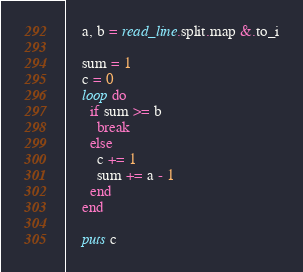<code> <loc_0><loc_0><loc_500><loc_500><_Crystal_>    a, b = read_line.split.map &.to_i

    sum = 1
    c = 0
    loop do
      if sum >= b
        break
      else
        c += 1
        sum += a - 1
      end
    end

    puts c</code> 